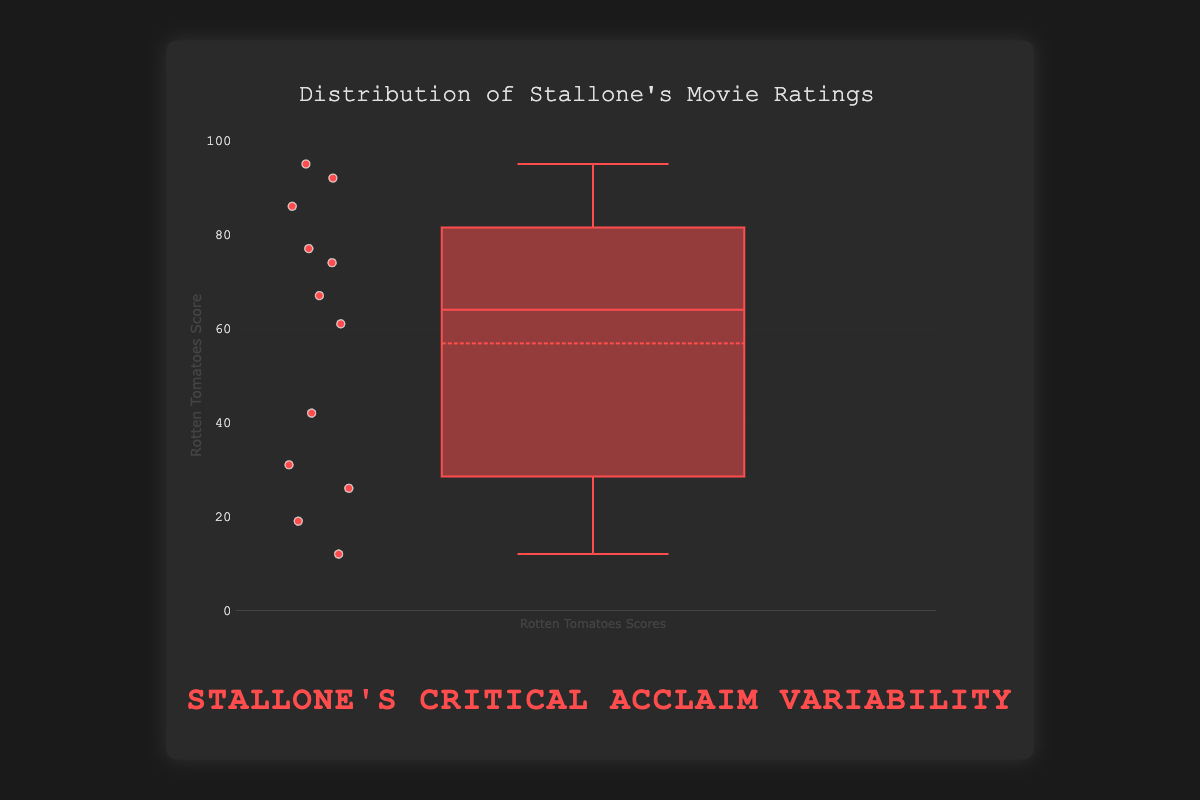What is the title of the figure? The title of the figure is usually located at the top of the plot. Here, it reads "Distribution of Stallone's Movie Ratings"
Answer: Distribution of Stallone's Movie Ratings What does the y-axis represent? The y-axis title is usually found on the left-hand side of the plot. It reads "Rotten Tomatoes Score," indicating that the y-axis represents the scores from Rotten Tomatoes for Stallone's movies.
Answer: Rotten Tomatoes Score How many data points are there in the plot? By counting the distinct points shown in the box plot, we can determine the number of data points. There are markers for each movie's score, giving us a total of 12 data points.
Answer: 12 What is the median Rotten Tomatoes score for Stallone's movies? In a box plot, the median is indicated by the line inside the box. Visually, we see the line around the score of 67.
Answer: 67 What is the range of Stallone's movie scores? The range in a box plot extends from the bottom of the whisker to the top of the whisker. The lowest score is 12 and the highest score is 95, so the range is 95 - 12 = 83.
Answer: 83 What is the interquartile range (IQR) of the scores? The IQR is determined by calculating the difference between the third quartile (upper boundary of the box) and the first quartile (lower boundary of the box). Visually, these appear to be approximately 86 and 31, respectively, so IQR = 86 - 31 = 55.
Answer: 55 Which movie has the highest Rotten Tomatoes score? The highest data point (outside the whiskers but marked individually) represents the highest scoring movie. Referring to the data, "Creed" has the highest score at 95.
Answer: Creed Which movie has the lowest Rotten Tomatoes score? The lowest data point (outside the whiskers but marked individually) represents the lowest scoring movie. Referring to the data, "Get Carter" has the lowest score at 12.
Answer: Get Carter How many outliers are there in the plot? In a box plot, outliers are indicated by individual points outside of the whiskers. These represent extreme values. Here, there are two such points.
Answer: 2 How does the variability of Stallone's movie ratings reflect his acting versatility? Variability in the box plot can be inferred from the spread of data points and the range. Stallone's movie ratings range widely from 12 to 95, showing he has been part of both critically acclaimed films and poorly received ones, underscoring his diverse role choices.
Answer: Wide range, indicating diverse role choices 